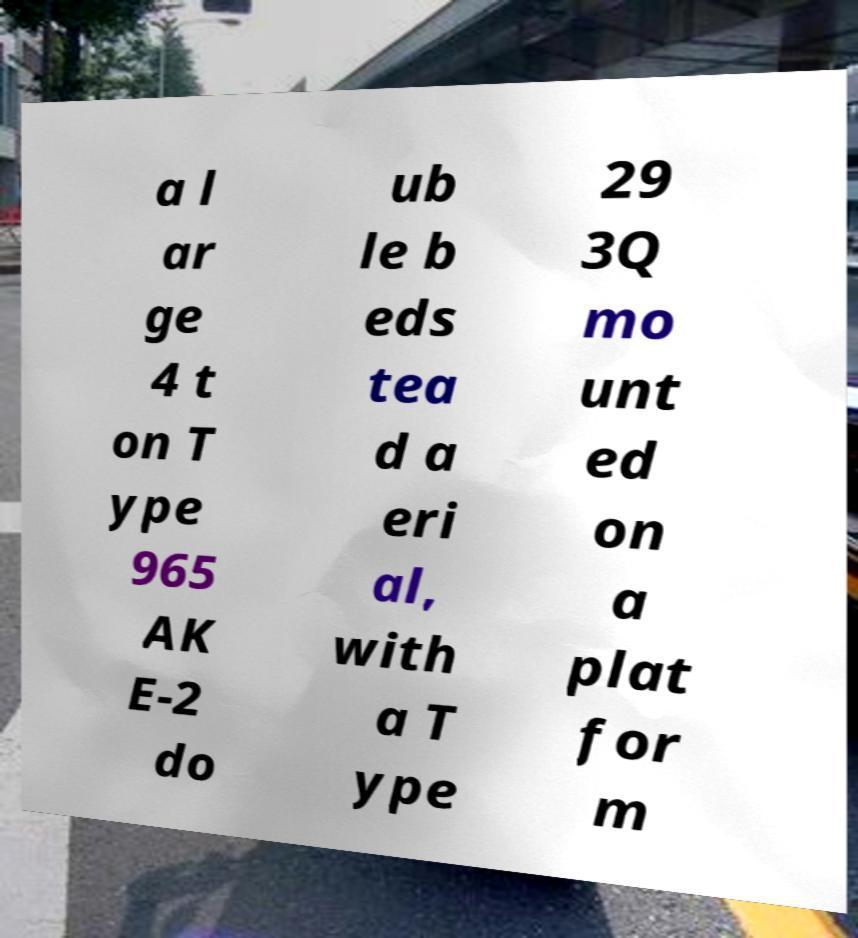Can you accurately transcribe the text from the provided image for me? a l ar ge 4 t on T ype 965 AK E-2 do ub le b eds tea d a eri al, with a T ype 29 3Q mo unt ed on a plat for m 